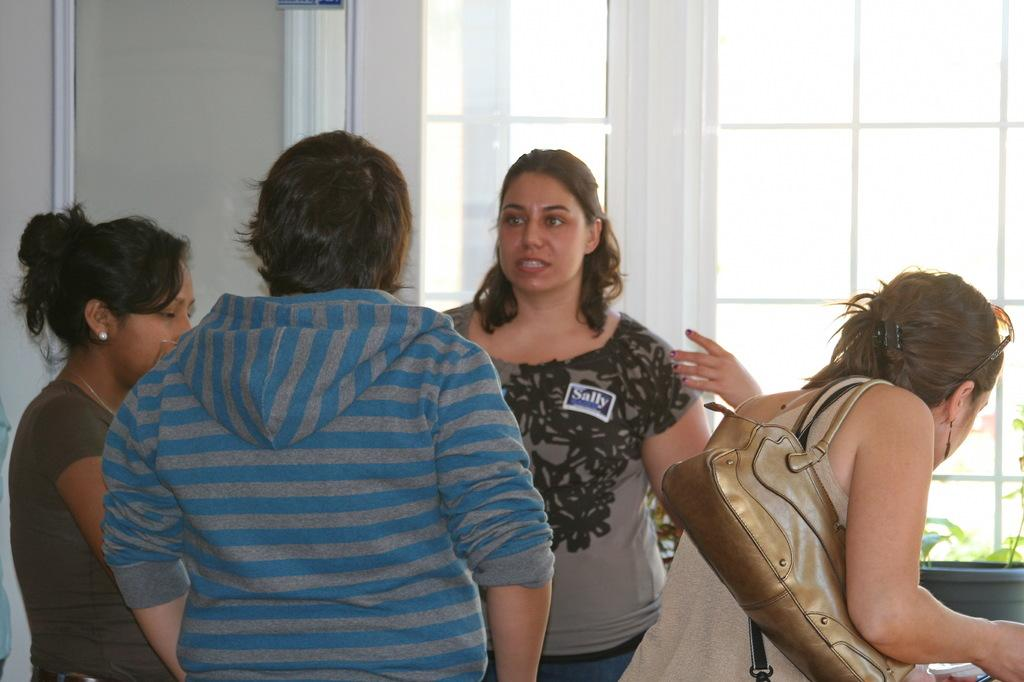How many people are in the group visible in the image? There is a group of people in the image, but the exact number cannot be determined without more specific information. What is visible in the background of the image? There is a wall and a window in the background of the image. What type of bird is perched on the peace sign in the image? There is no bird or peace sign present in the image. How does the group of people in the image draw attention to themselves? The image does not provide information about how the group of people might draw attention to themselves. 